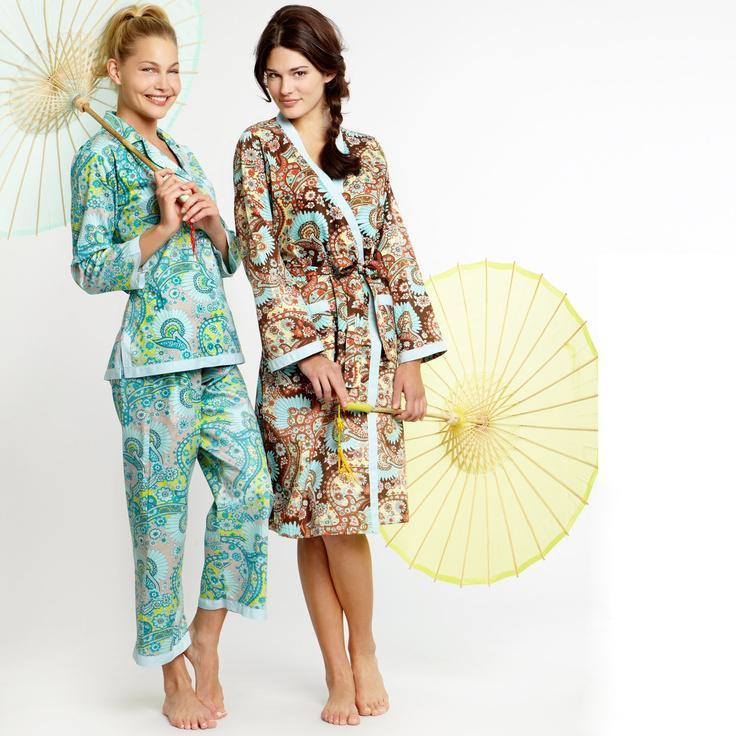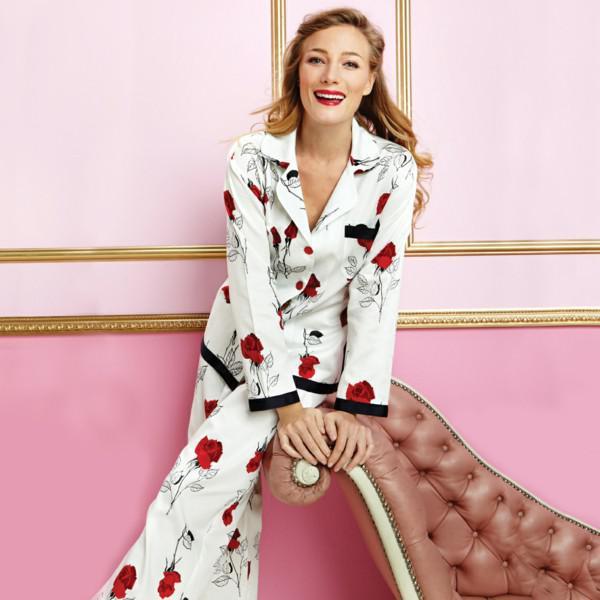The first image is the image on the left, the second image is the image on the right. Evaluate the accuracy of this statement regarding the images: "A pajama shirt in one image has solid contrasting trim on the shirt's bottom hem, pocket, and sleeve cuffs.". Is it true? Answer yes or no. Yes. The first image is the image on the left, the second image is the image on the right. Evaluate the accuracy of this statement regarding the images: "Right image shows one model in pajamas with solid trim at the hems.". Is it true? Answer yes or no. Yes. 